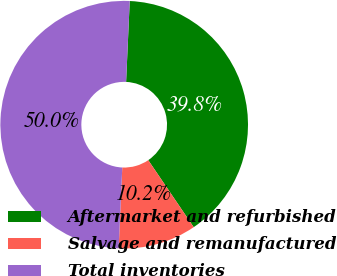<chart> <loc_0><loc_0><loc_500><loc_500><pie_chart><fcel>Aftermarket and refurbished<fcel>Salvage and remanufactured<fcel>Total inventories<nl><fcel>39.8%<fcel>10.2%<fcel>50.0%<nl></chart> 